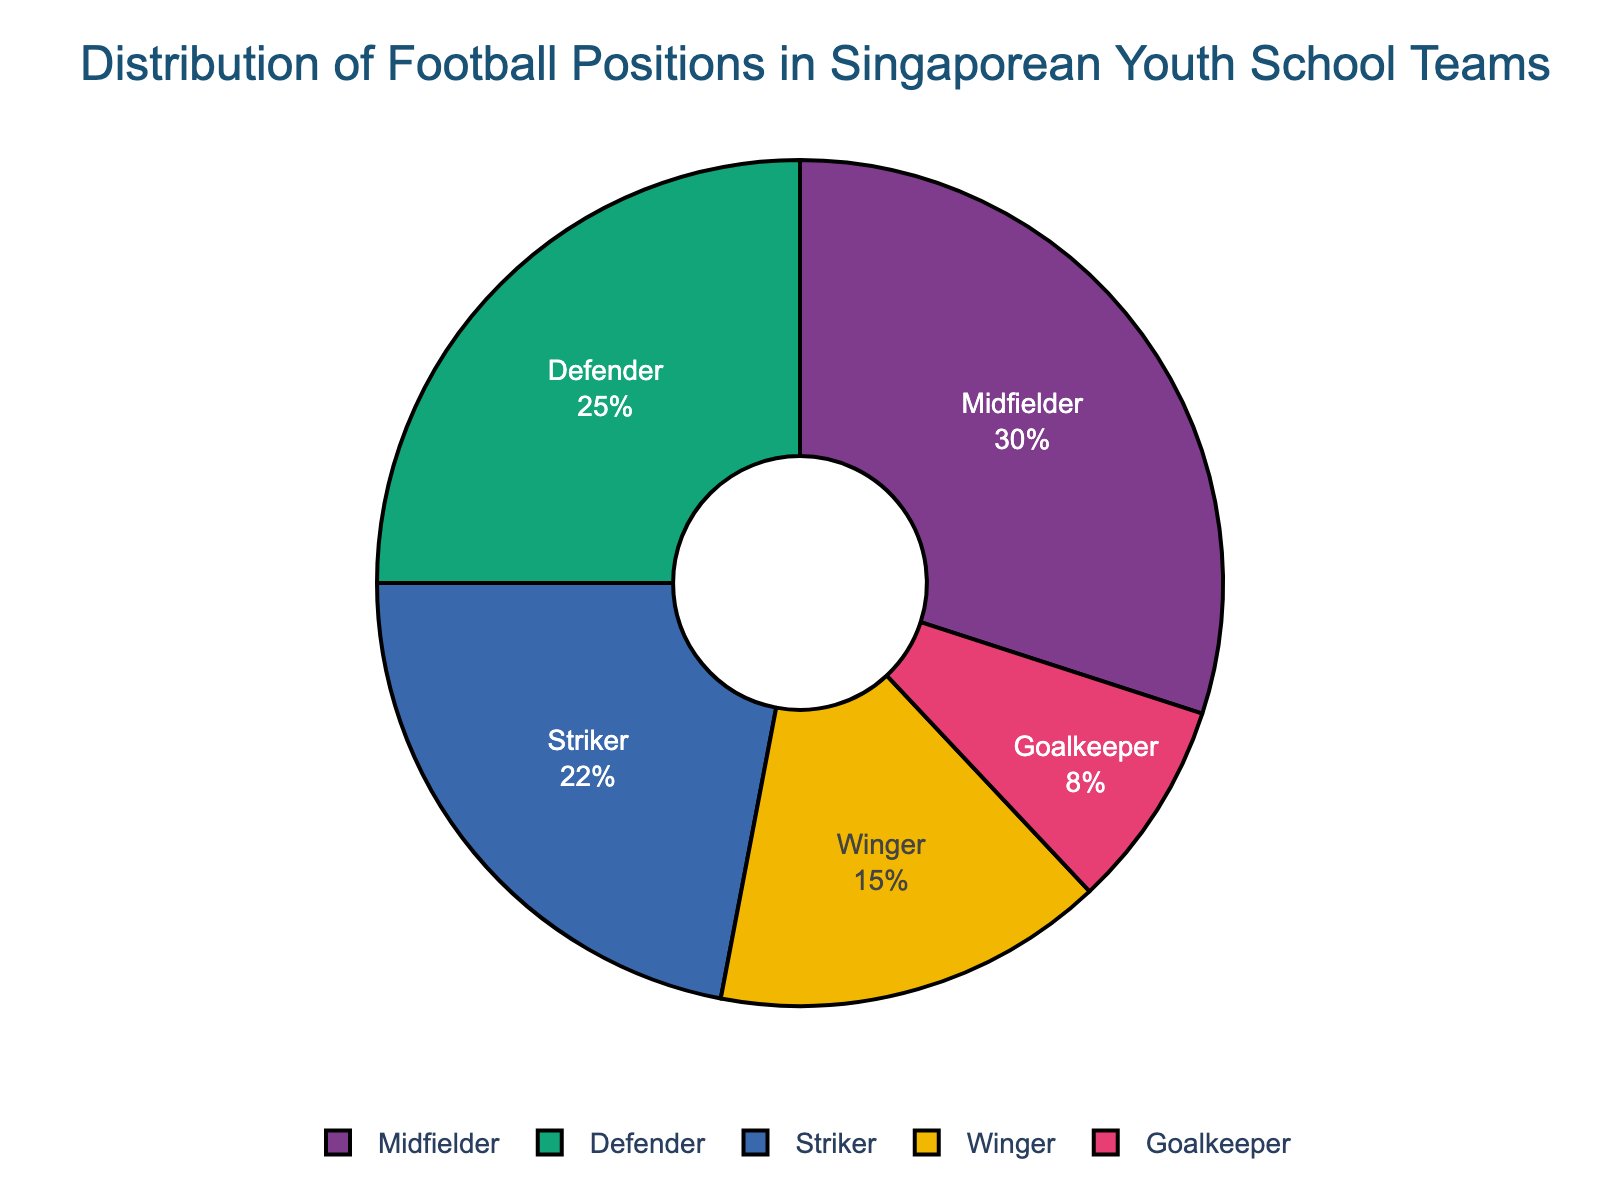What is the most common football position played by Singaporean youth in school teams? To find the most common position, look for the sector with the largest percentage. The largest slice is represented by the "Midfielder" at 30%.
Answer: Midfielder Which football position is the least common? The smallest slice of the pie chart represents the least common position. This is the "Goalkeeper" with 8%.
Answer: Goalkeeper How many percentage points more is the Midfielder position compared to the Goalkeeper position? To find the difference, subtract the percentage of the Goalkeeper from the Midfielder. This is 30% - 8% = 22 percentage points.
Answer: 22 What two positions combined make up 47% of the distribution? Identify the positions and sum their percentages until you reach or exceed 47%. The Striker and Defender combined make up 22% + 25% = 47%.
Answer: Striker and Defender What is the total percentage of defensive positions (Defender and Goalkeeper) among Singaporean youth in school teams? Add the percentages of Defender and Goalkeeper. This is 25% + 8% = 33%.
Answer: 33% How does the percentage of Winger position compare to Striker? Compare the two percentages directly. The Winger position is at 15% and the Striker is at 22%, so Winger is 7 percentage points less than Striker.
Answer: 7 percentage points less How many percentage points less is the Goalkeeper position compared to the sum of Striker and Winger? First, find the sum of Striker and Winger percentages: 22% + 15% = 37%. Then, subtract Goalkeeper's percentage from this sum: 37% - 8% = 29 percentage points.
Answer: 29 What is the average percentage of non-striker positions played (Midfielder, Defender, Goalkeeper, Winger)? Sum up the percentages of the non-striker positions and then divide by the number of those positions. (30% + 25% + 8% + 15%) / 4 = 78% / 4 = 19.5%.
Answer: 19.5% Which position has the highest percentage and what color represents it in the pie chart? Identify the largest slice in the chart and note its color. The Midfielder has the highest percentage at 30% and is represented by a specific color from the color palette (typically blue, green, red, or similar).
Answer: Midfielder and its color (may vary based on the palette used) If the sum of Defender and Goalkeeper positions is considered "defensive positions," what percentage is needed from another position to reach 50% total? First, sum the defensive positions: 25% + 8% = 33%. To reach 50%, subtract this total from 50%: 50% - 33% = 17%.
Answer: 17% 